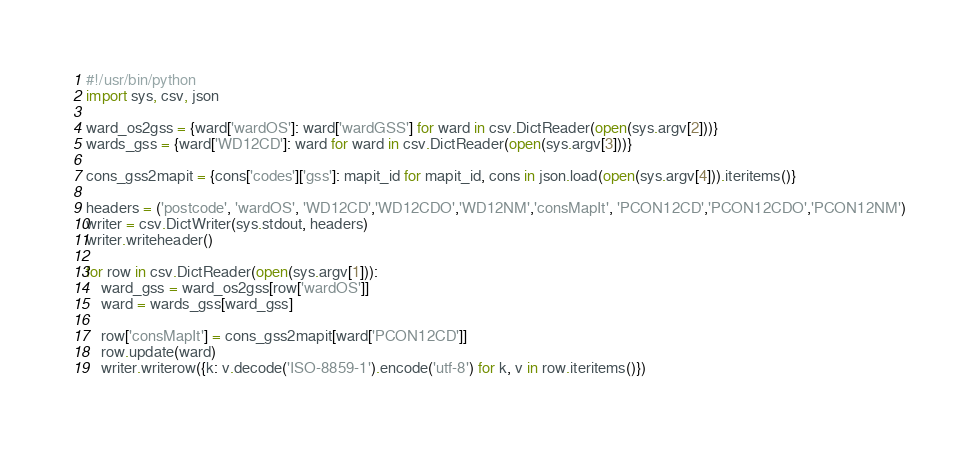Convert code to text. <code><loc_0><loc_0><loc_500><loc_500><_Python_>#!/usr/bin/python
import sys, csv, json

ward_os2gss = {ward['wardOS']: ward['wardGSS'] for ward in csv.DictReader(open(sys.argv[2]))}
wards_gss = {ward['WD12CD']: ward for ward in csv.DictReader(open(sys.argv[3]))}

cons_gss2mapit = {cons['codes']['gss']: mapit_id for mapit_id, cons in json.load(open(sys.argv[4])).iteritems()}

headers = ('postcode', 'wardOS', 'WD12CD','WD12CDO','WD12NM','consMapIt', 'PCON12CD','PCON12CDO','PCON12NM')
writer = csv.DictWriter(sys.stdout, headers)
writer.writeheader()

for row in csv.DictReader(open(sys.argv[1])):
    ward_gss = ward_os2gss[row['wardOS']]
    ward = wards_gss[ward_gss]

    row['consMapIt'] = cons_gss2mapit[ward['PCON12CD']]
    row.update(ward)
    writer.writerow({k: v.decode('ISO-8859-1').encode('utf-8') for k, v in row.iteritems()})
</code> 